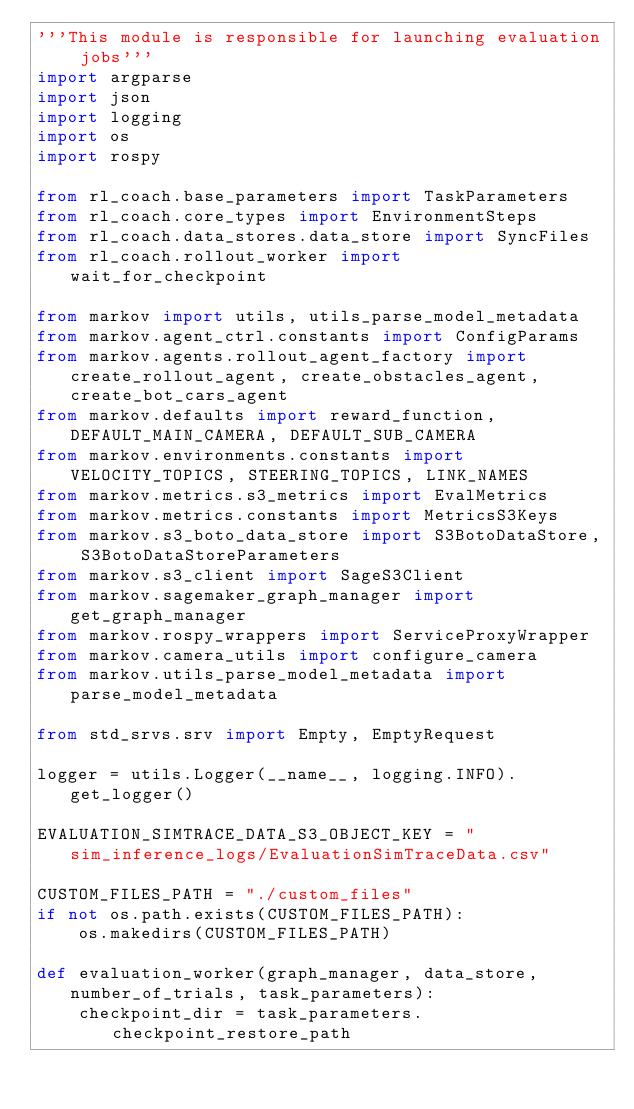Convert code to text. <code><loc_0><loc_0><loc_500><loc_500><_Python_>'''This module is responsible for launching evaluation jobs'''
import argparse
import json
import logging
import os
import rospy

from rl_coach.base_parameters import TaskParameters
from rl_coach.core_types import EnvironmentSteps
from rl_coach.data_stores.data_store import SyncFiles
from rl_coach.rollout_worker import wait_for_checkpoint

from markov import utils, utils_parse_model_metadata
from markov.agent_ctrl.constants import ConfigParams
from markov.agents.rollout_agent_factory import create_rollout_agent, create_obstacles_agent, create_bot_cars_agent
from markov.defaults import reward_function, DEFAULT_MAIN_CAMERA, DEFAULT_SUB_CAMERA
from markov.environments.constants import VELOCITY_TOPICS, STEERING_TOPICS, LINK_NAMES
from markov.metrics.s3_metrics import EvalMetrics
from markov.metrics.constants import MetricsS3Keys
from markov.s3_boto_data_store import S3BotoDataStore, S3BotoDataStoreParameters
from markov.s3_client import SageS3Client
from markov.sagemaker_graph_manager import get_graph_manager
from markov.rospy_wrappers import ServiceProxyWrapper
from markov.camera_utils import configure_camera
from markov.utils_parse_model_metadata import parse_model_metadata

from std_srvs.srv import Empty, EmptyRequest

logger = utils.Logger(__name__, logging.INFO).get_logger()

EVALUATION_SIMTRACE_DATA_S3_OBJECT_KEY = "sim_inference_logs/EvaluationSimTraceData.csv"

CUSTOM_FILES_PATH = "./custom_files"
if not os.path.exists(CUSTOM_FILES_PATH):
    os.makedirs(CUSTOM_FILES_PATH)

def evaluation_worker(graph_manager, data_store, number_of_trials, task_parameters):
    checkpoint_dir = task_parameters.checkpoint_restore_path</code> 